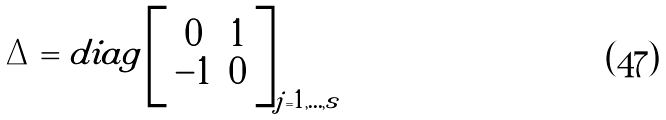Convert formula to latex. <formula><loc_0><loc_0><loc_500><loc_500>\Delta = d i a g \left [ \begin{array} { c c } 0 & 1 \\ - 1 & 0 \end{array} \right ] _ { j = 1 , \dots , s }</formula> 